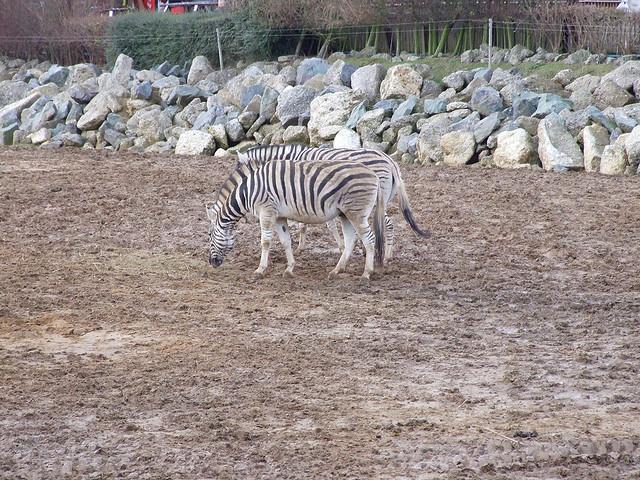How many zebras can be seen?
Give a very brief answer. 2. How many sandwiches with orange paste are in the picture?
Give a very brief answer. 0. 